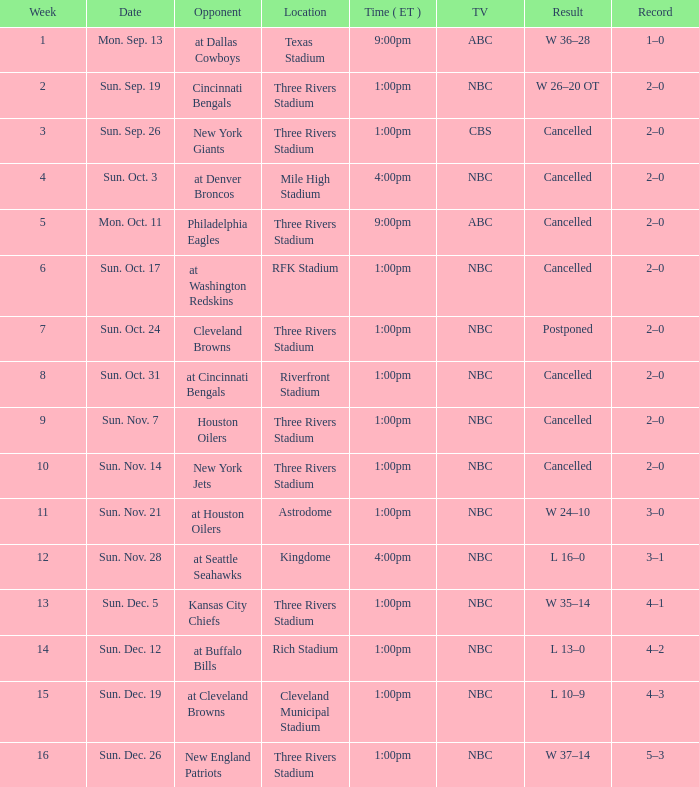What time in eastern standard time was game held at denver broncos? 4:00pm. 